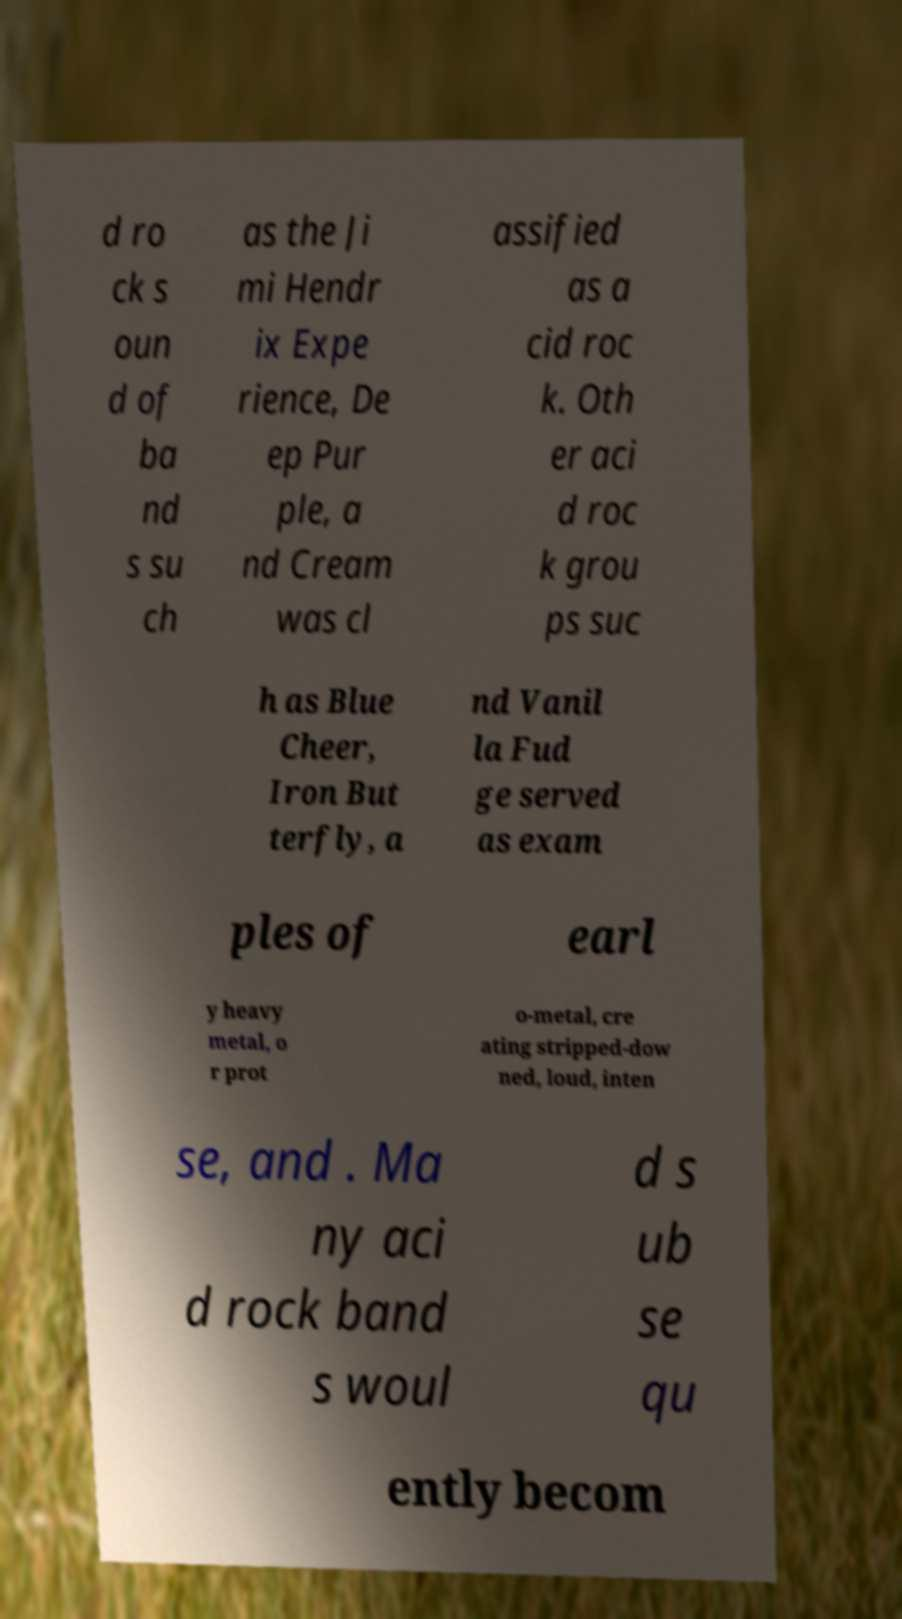Can you read and provide the text displayed in the image?This photo seems to have some interesting text. Can you extract and type it out for me? d ro ck s oun d of ba nd s su ch as the Ji mi Hendr ix Expe rience, De ep Pur ple, a nd Cream was cl assified as a cid roc k. Oth er aci d roc k grou ps suc h as Blue Cheer, Iron But terfly, a nd Vanil la Fud ge served as exam ples of earl y heavy metal, o r prot o-metal, cre ating stripped-dow ned, loud, inten se, and . Ma ny aci d rock band s woul d s ub se qu ently becom 